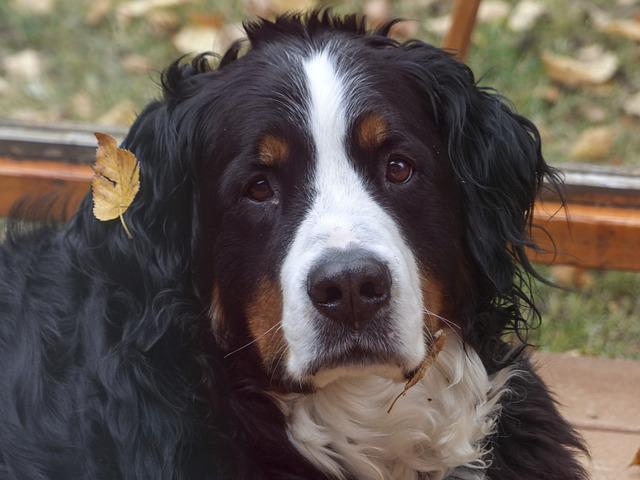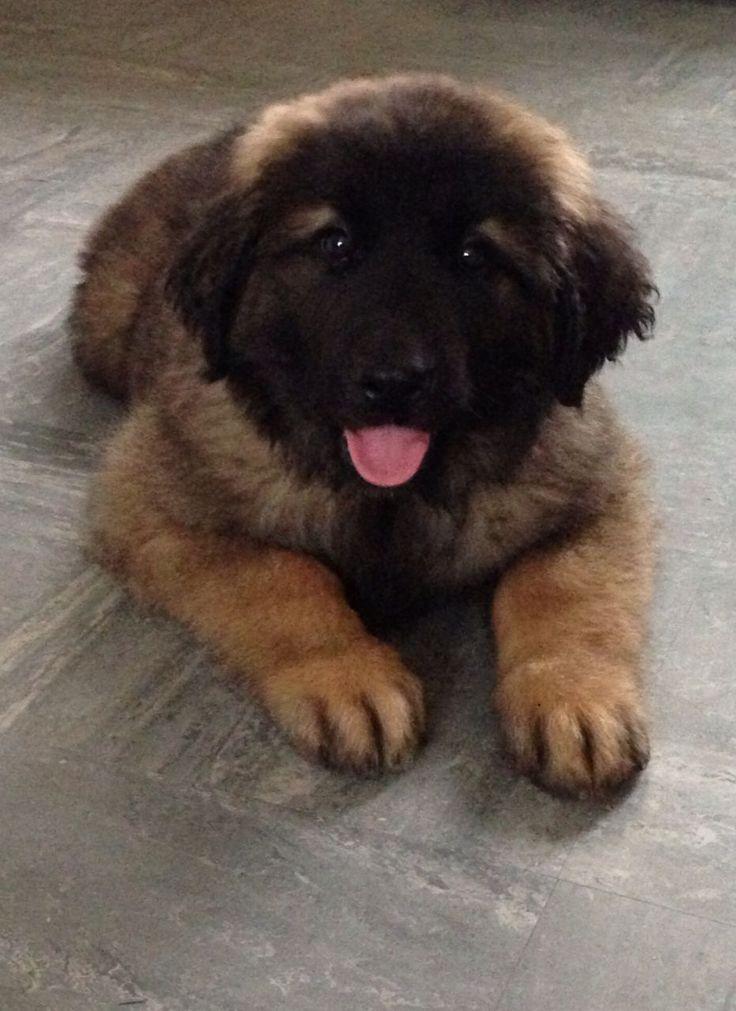The first image is the image on the left, the second image is the image on the right. Assess this claim about the two images: "There are a total of exactly two dogs.". Correct or not? Answer yes or no. Yes. The first image is the image on the left, the second image is the image on the right. Considering the images on both sides, is "There are at most two dogs." valid? Answer yes or no. Yes. 